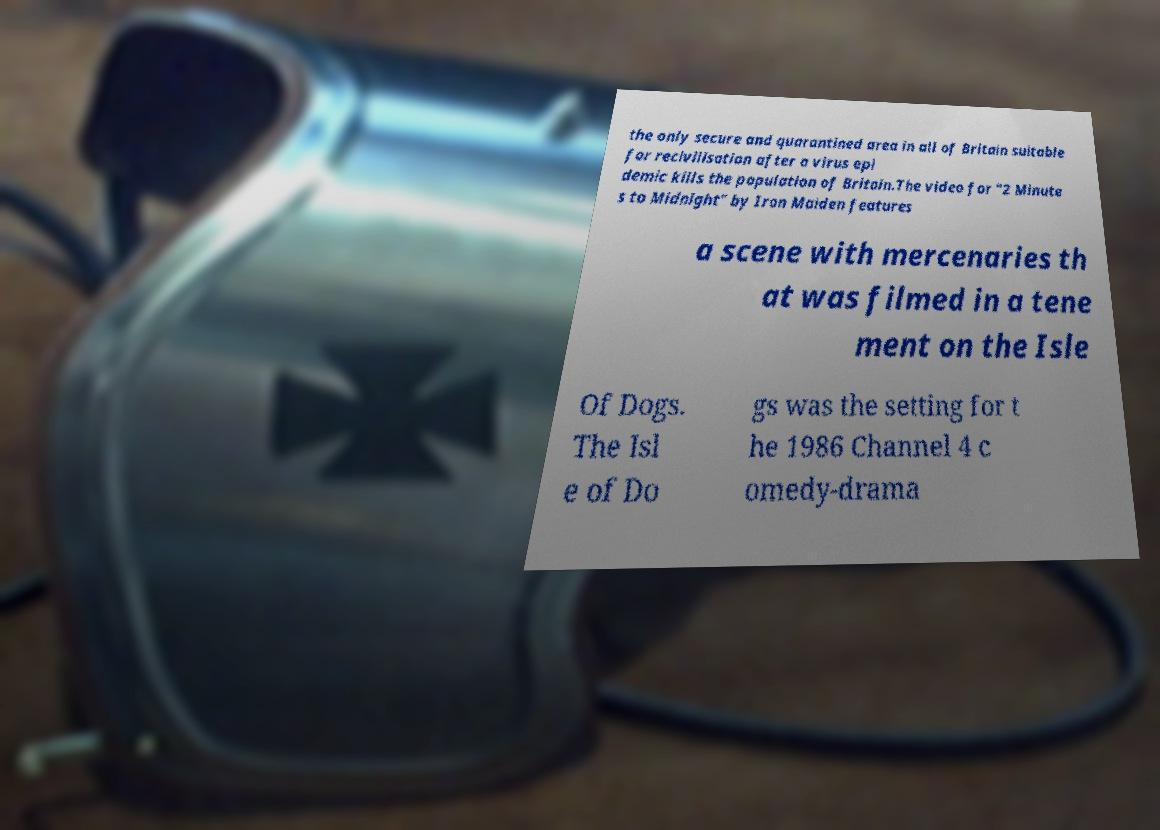What messages or text are displayed in this image? I need them in a readable, typed format. the only secure and quarantined area in all of Britain suitable for recivilisation after a virus epi demic kills the population of Britain.The video for "2 Minute s to Midnight" by Iron Maiden features a scene with mercenaries th at was filmed in a tene ment on the Isle Of Dogs. The Isl e of Do gs was the setting for t he 1986 Channel 4 c omedy-drama 